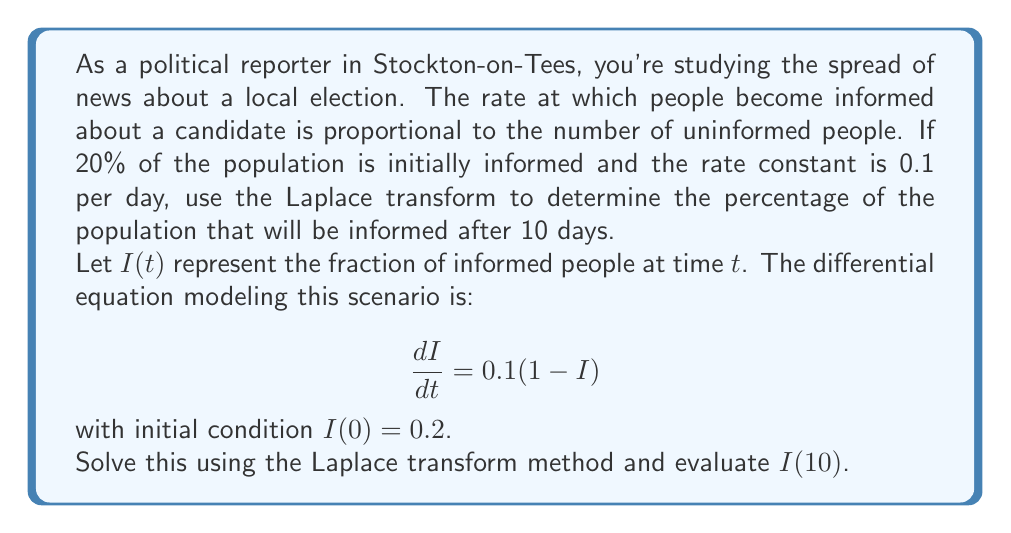Provide a solution to this math problem. Let's solve this step-by-step using the Laplace transform:

1) Take the Laplace transform of both sides of the equation:
   $$\mathcal{L}\left\{\frac{dI}{dt}\right\} = 0.1\mathcal{L}\{1-I\}$$

2) Using Laplace transform properties:
   $$s\mathcal{L}\{I\} - I(0) = 0.1\left(\frac{1}{s} - \mathcal{L}\{I\}\right)$$

3) Substitute $I(0) = 0.2$ and let $\mathcal{L}\{I\} = Y(s)$:
   $$sY(s) - 0.2 = \frac{0.1}{s} - 0.1Y(s)$$

4) Rearrange the equation:
   $$(s+0.1)Y(s) = 0.2 + \frac{0.1}{s}$$

5) Solve for $Y(s)$:
   $$Y(s) = \frac{0.2}{s+0.1} + \frac{0.1}{s(s+0.1)}$$

6) Perform partial fraction decomposition:
   $$Y(s) = \frac{0.2}{s+0.1} + \frac{1}{s} - \frac{1}{s+0.1}$$

7) Take the inverse Laplace transform:
   $$I(t) = 0.2e^{-0.1t} + 1 - e^{-0.1t} = 1 - 0.8e^{-0.1t}$$

8) Evaluate $I(10)$:
   $$I(10) = 1 - 0.8e^{-0.1(10)} = 1 - 0.8e^{-1} \approx 0.7052$$

Therefore, after 10 days, approximately 70.52% of the population will be informed.
Answer: $70.52\%$ 